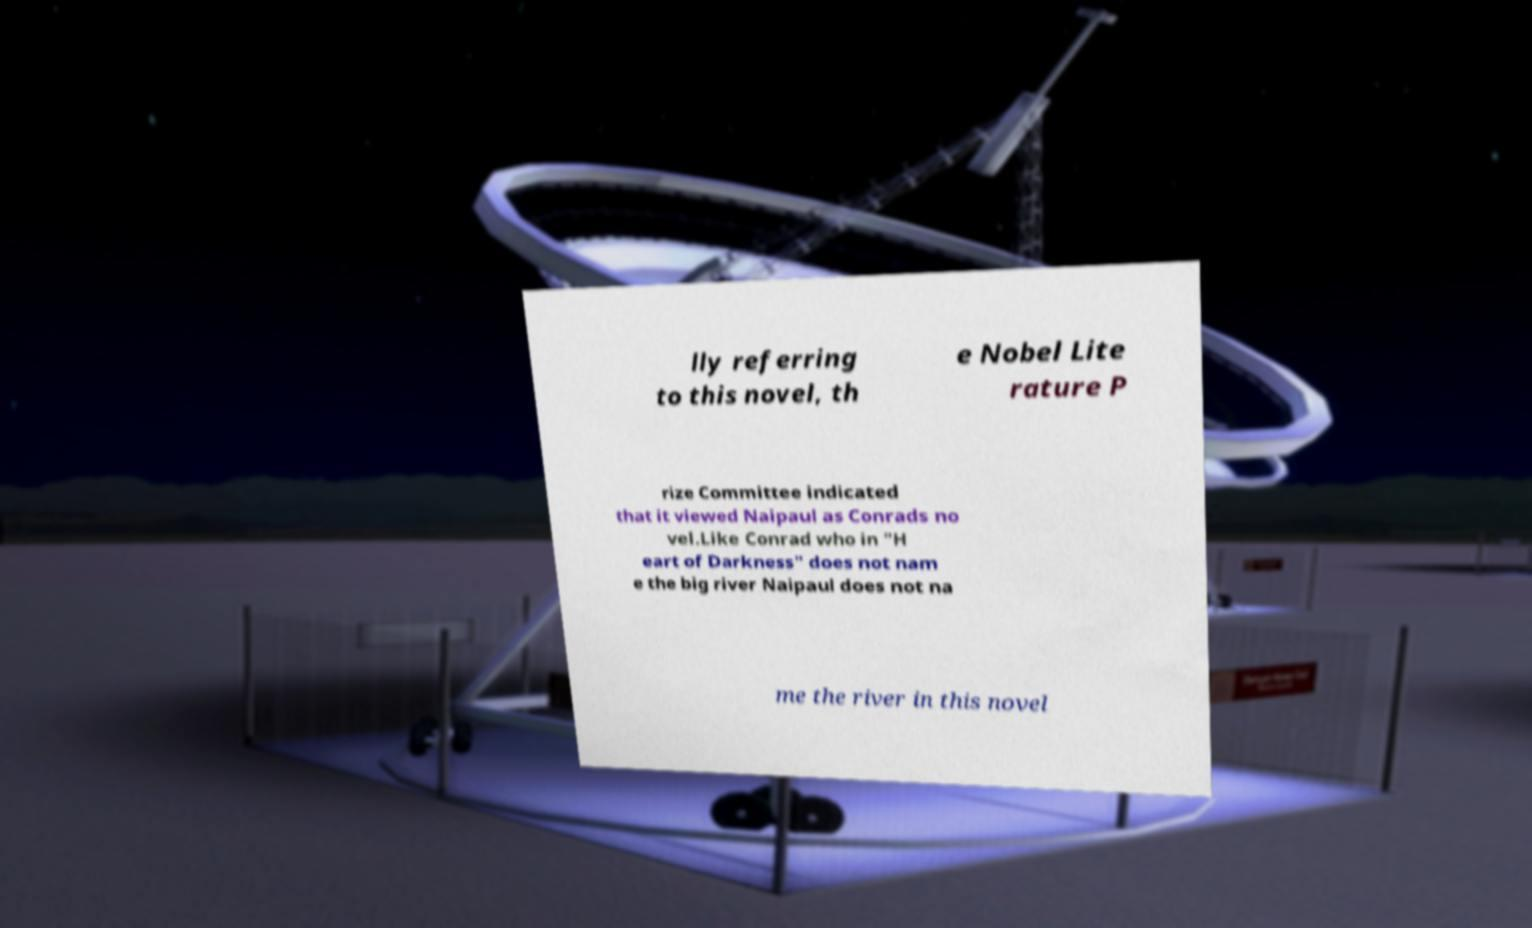Please read and relay the text visible in this image. What does it say? lly referring to this novel, th e Nobel Lite rature P rize Committee indicated that it viewed Naipaul as Conrads no vel.Like Conrad who in "H eart of Darkness" does not nam e the big river Naipaul does not na me the river in this novel 